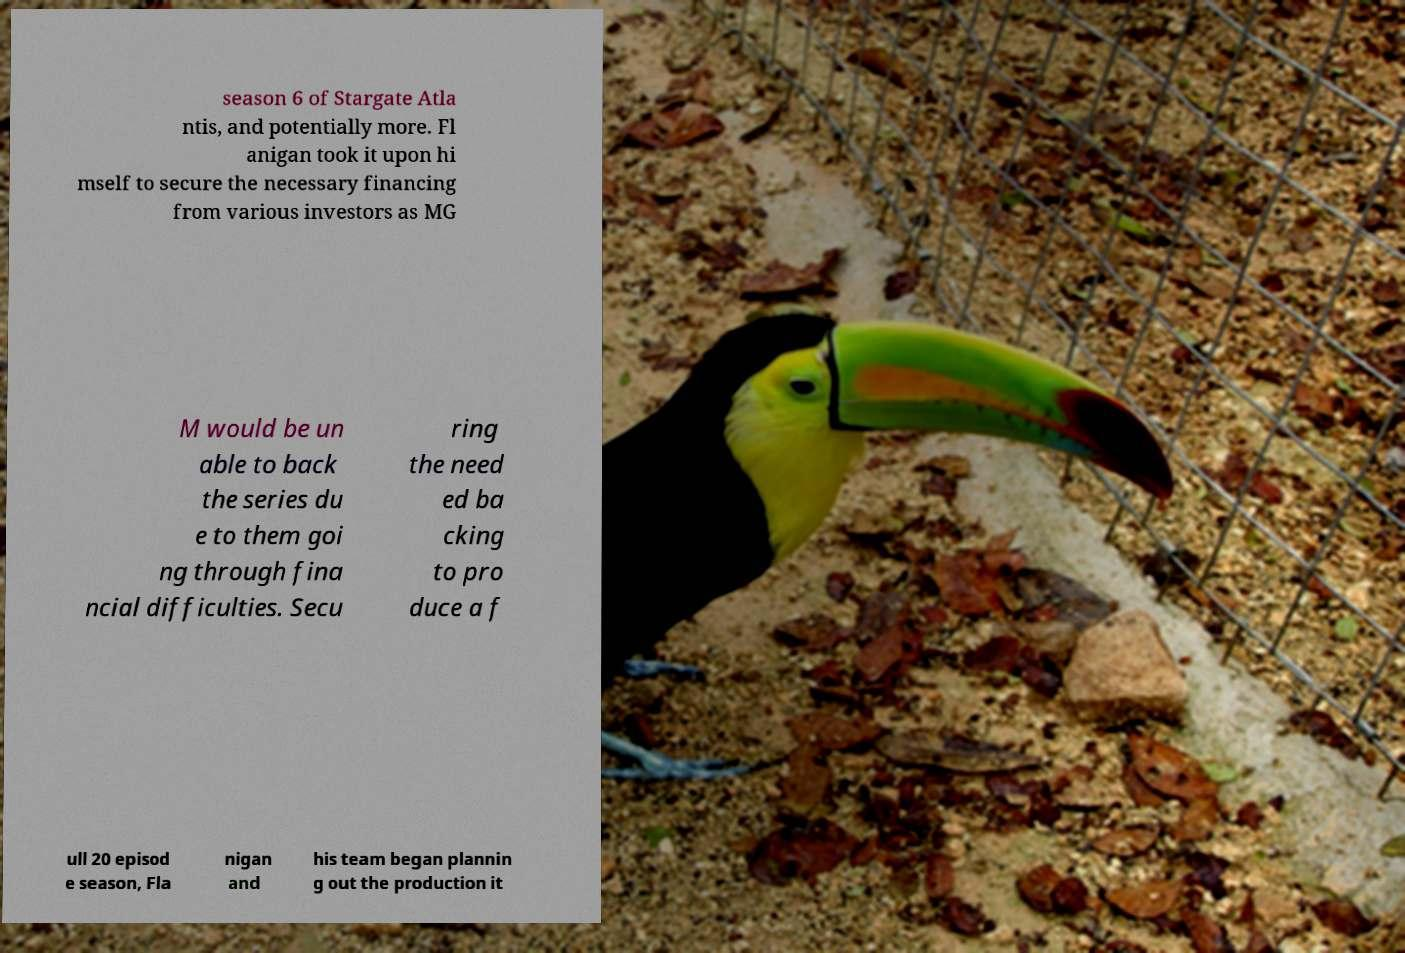For documentation purposes, I need the text within this image transcribed. Could you provide that? season 6 of Stargate Atla ntis, and potentially more. Fl anigan took it upon hi mself to secure the necessary financing from various investors as MG M would be un able to back the series du e to them goi ng through fina ncial difficulties. Secu ring the need ed ba cking to pro duce a f ull 20 episod e season, Fla nigan and his team began plannin g out the production it 